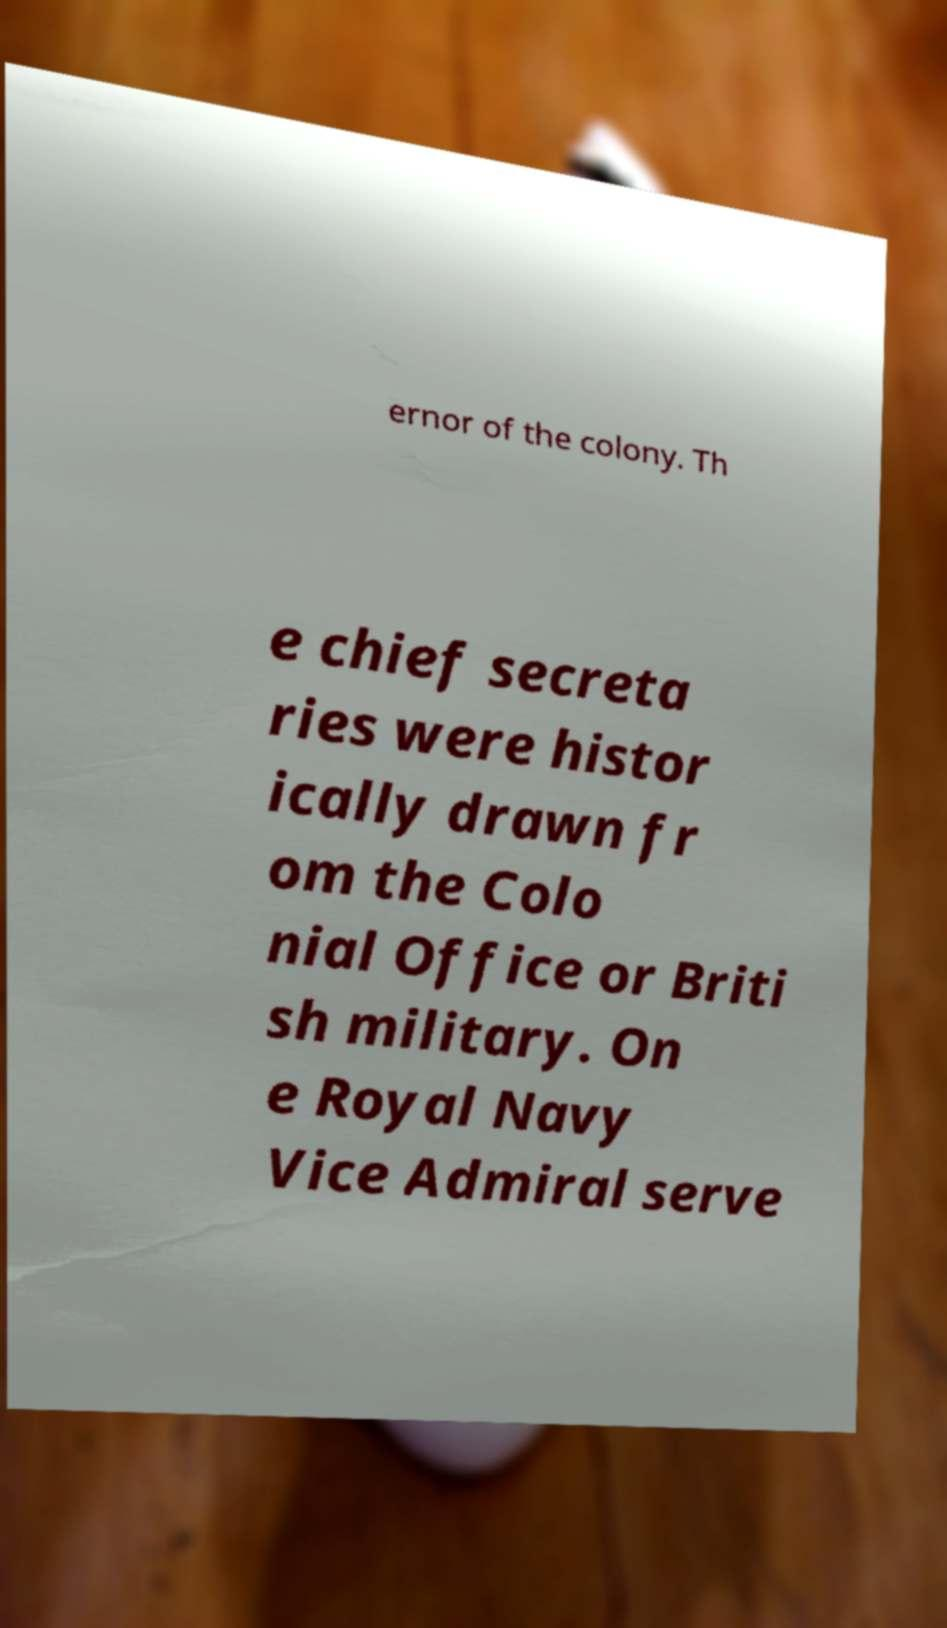Could you extract and type out the text from this image? ernor of the colony. Th e chief secreta ries were histor ically drawn fr om the Colo nial Office or Briti sh military. On e Royal Navy Vice Admiral serve 